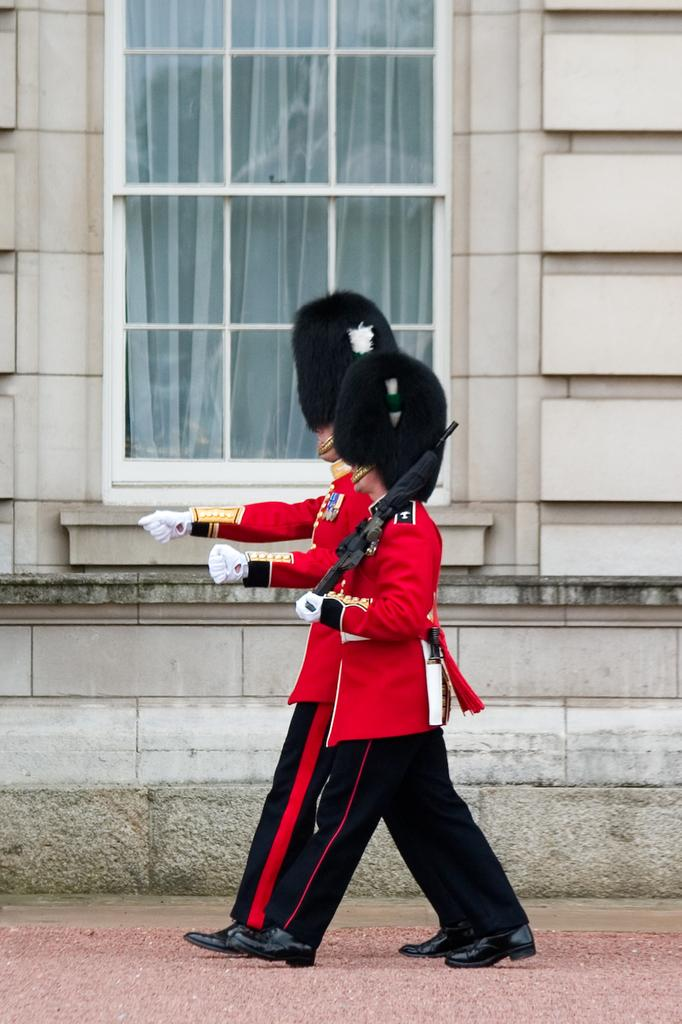What are the people in the image doing? The people in the image are walking. What object is the man holding in his hand? The man appears to be holding a gun in his hand. What can be seen in the distance in the image? There is a building in the background of the image. Can you describe any specific architectural features in the image? There is a glass window visible in the image. How does the hydrant burst in the image? There is no hydrant present in the image, so it cannot burst. What type of quiver is the man holding in his hand? The man is not holding a quiver in his hand; he is holding a gun. 